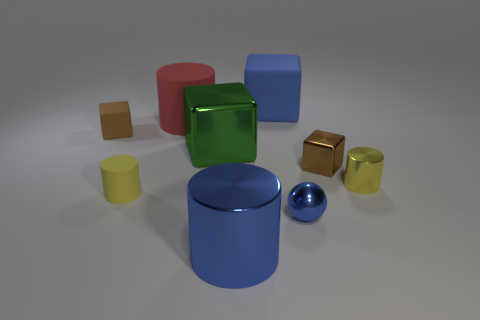How is the lighting affecting the mood of this scene? The lighting in this scene casts gentle shadows and creates soft reflections on the glossy surfaces, conveying a calm and serene atmosphere. It's soft and diffused, suggesting a controlled environment where the interplay of light and color can be appreciated without harsh distractions. 